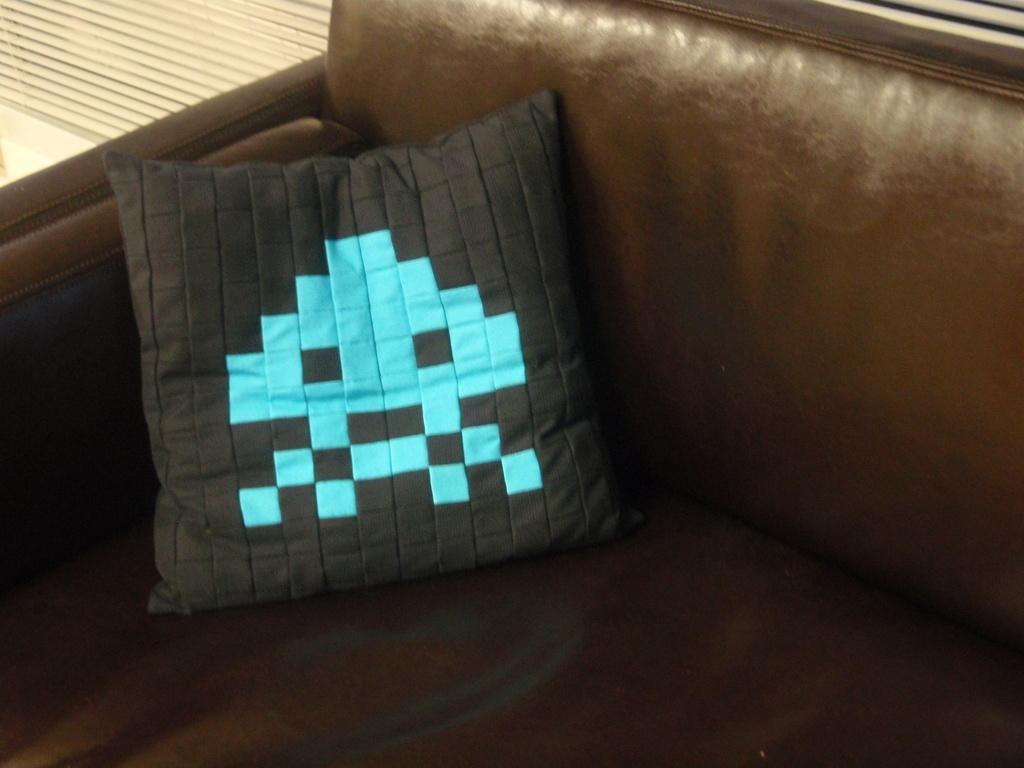What type of furniture is in the image? There is a sofa in the image. What is placed on the sofa? There is a pillow on the sofa. Can you describe the background of the image? There is an object visible in the background of the image. How many pigs are playing cards on the sofa in the image? There are no pigs or playing cards present in the image. 